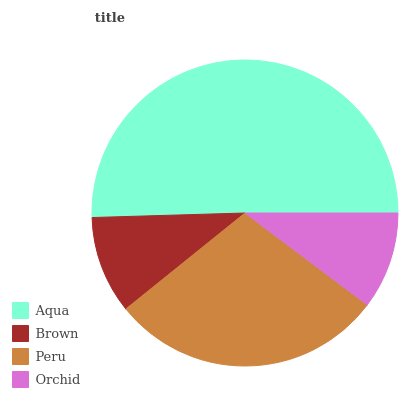Is Orchid the minimum?
Answer yes or no. Yes. Is Aqua the maximum?
Answer yes or no. Yes. Is Brown the minimum?
Answer yes or no. No. Is Brown the maximum?
Answer yes or no. No. Is Aqua greater than Brown?
Answer yes or no. Yes. Is Brown less than Aqua?
Answer yes or no. Yes. Is Brown greater than Aqua?
Answer yes or no. No. Is Aqua less than Brown?
Answer yes or no. No. Is Peru the high median?
Answer yes or no. Yes. Is Brown the low median?
Answer yes or no. Yes. Is Brown the high median?
Answer yes or no. No. Is Aqua the low median?
Answer yes or no. No. 